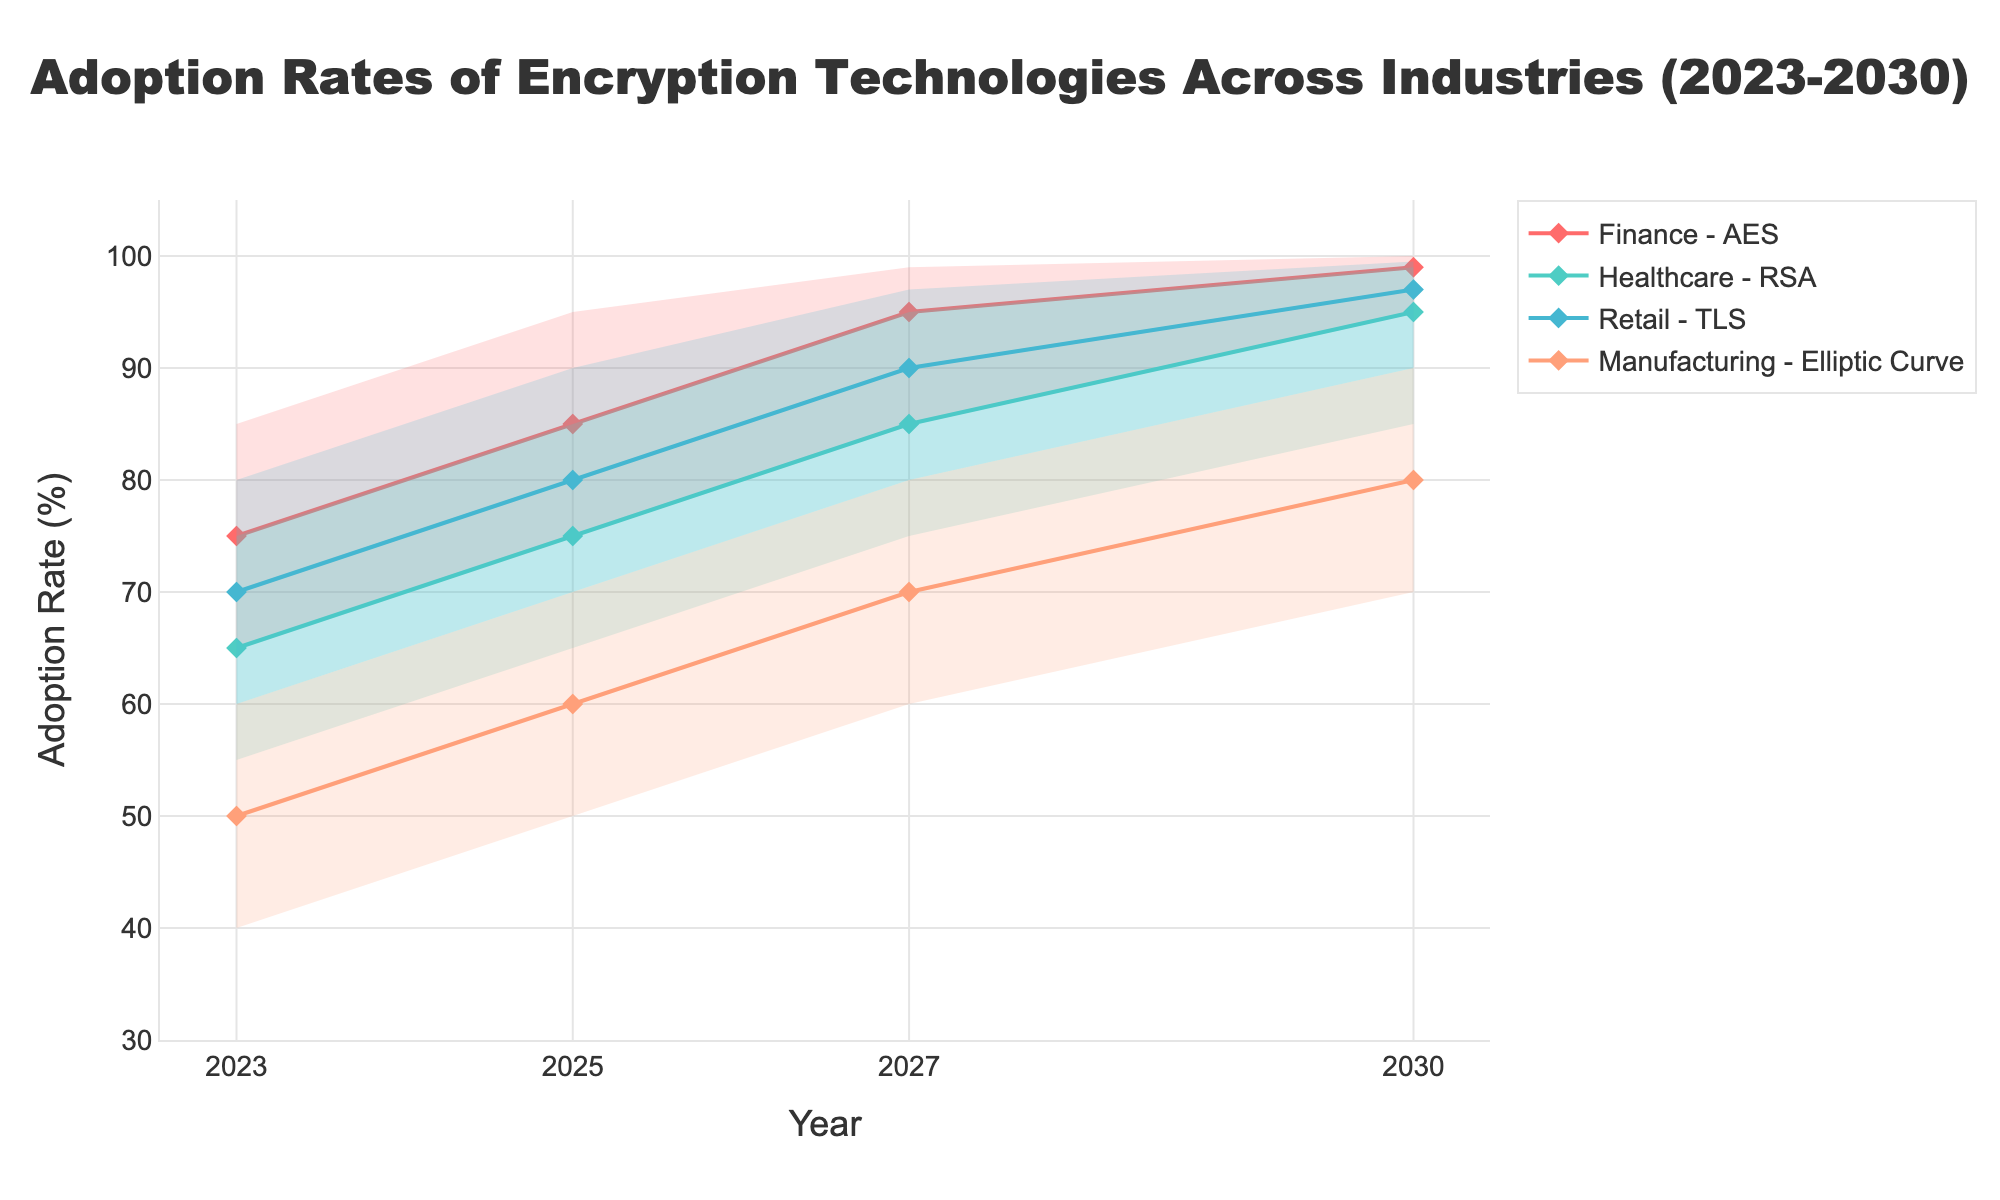What is the title of the figure? The title is displayed at the top center of the chart. It is written in larger font size to grab attention. It reads "Adoption Rates of Encryption Technologies Across Industries (2023-2030)".
Answer: Adoption Rates of Encryption Technologies Across Industries (2023-2030) What industry uses AES technology and what are its adoption rates over the years? Each industry is labeled and paired with its respective technology throughout the chart. For each year, the adoption rates are detailed across different percentiles (Low, Low-Mid, Mid, Mid-High, High). The Finance industry uses AES technology with adoption rates in 2023 (65-85%), in 2025 (75-95%), in 2027 (85-99%), and in 2030 (95-100%).
Answer: Finance Which industry shows the highest adoption rate in 2030, and what is the rate? To determine the highest adoption rate in 2030, one must examine each industry data label for the year 2030. The Finance industry has the highest adoption rate with AES technology, reaching up to 100%.
Answer: Finance, 100% Compare the adoption trajectory of Elliptic Curve technology in Manufacturing from 2023 to 2030. How much did the median value increase? Review the median values for the years specified for Elliptic Curve technology in Manufacturing. The median values are 50% in 2023, 60% in 2025, 70% in 2027, and 80% in 2030. Subtract the initial value (2023) from the final value (2030) to find the increase: 80% - 50% = 30%.
Answer: 30% Which industry has the fastest growth in adoption rates from 2023 to 2027, and by how much does the mid value increase? Analyze the mid values for each industry from 2023 to 2027 and then determine the differences. The finance industry (AES) grows from 75% in 2023 to 95% in 2027, increasing by 20%, which is faster than others.
Answer: Finance, 20% What is the range of adoption rates for RSA technology in Healthcare in 2025? Locate the data for Healthcare using RSA technology in the year 2025. The adoption rates span from the Low value to the High value, which are 65% and 85%, respectively.
Answer: 65%-85% Which technology shows the most consistent adoption rate across different percentiles in any single year, and what is the range? Examine each technology's adoption rate percentiles for one year to determine which has the smallest range. For AES in 2030, the range is from 95% to 100%, making this the most consistent adoption.
Answer: AES in 2030, 95%-100% What adoption rate does TLS technology in Retail achieve by 2025 at its mid-high percentile? Locate TLS technology adoption rates in Retail for the year 2025 at the mid-high percentile. It peaks at 85%.
Answer: 85% 